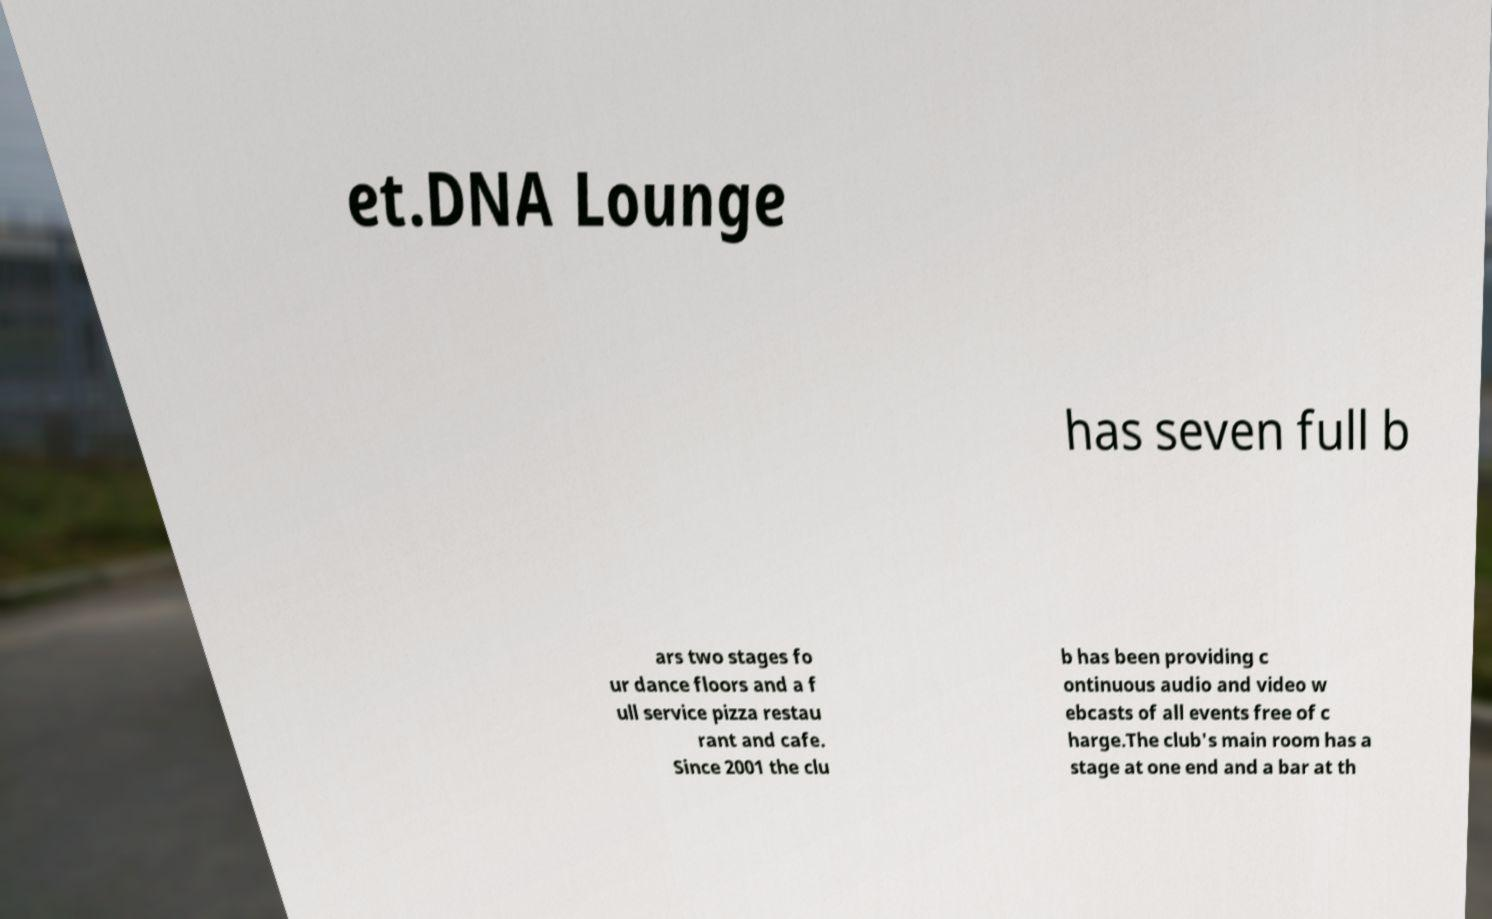There's text embedded in this image that I need extracted. Can you transcribe it verbatim? et.DNA Lounge has seven full b ars two stages fo ur dance floors and a f ull service pizza restau rant and cafe. Since 2001 the clu b has been providing c ontinuous audio and video w ebcasts of all events free of c harge.The club's main room has a stage at one end and a bar at th 